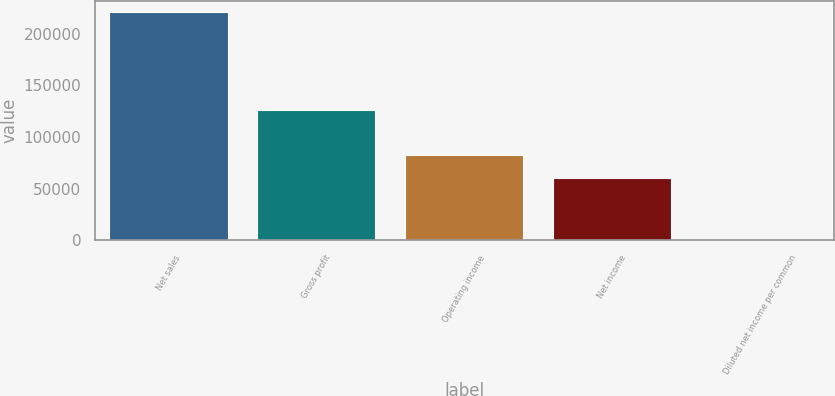Convert chart. <chart><loc_0><loc_0><loc_500><loc_500><bar_chart><fcel>Net sales<fcel>Gross profit<fcel>Operating income<fcel>Net income<fcel>Diluted net income per common<nl><fcel>220694<fcel>126377<fcel>82512.4<fcel>60443<fcel>0.29<nl></chart> 